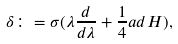<formula> <loc_0><loc_0><loc_500><loc_500>\delta \colon = \sigma ( \lambda \frac { d } { d \lambda } + \frac { 1 } { 4 } a d H ) ,</formula> 